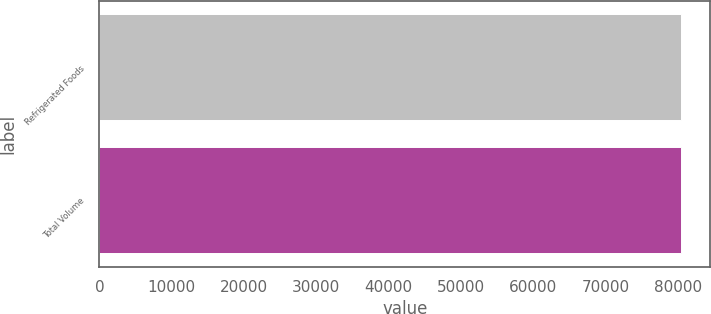<chart> <loc_0><loc_0><loc_500><loc_500><bar_chart><fcel>Refrigerated Foods<fcel>Total Volume<nl><fcel>80454<fcel>80454.1<nl></chart> 